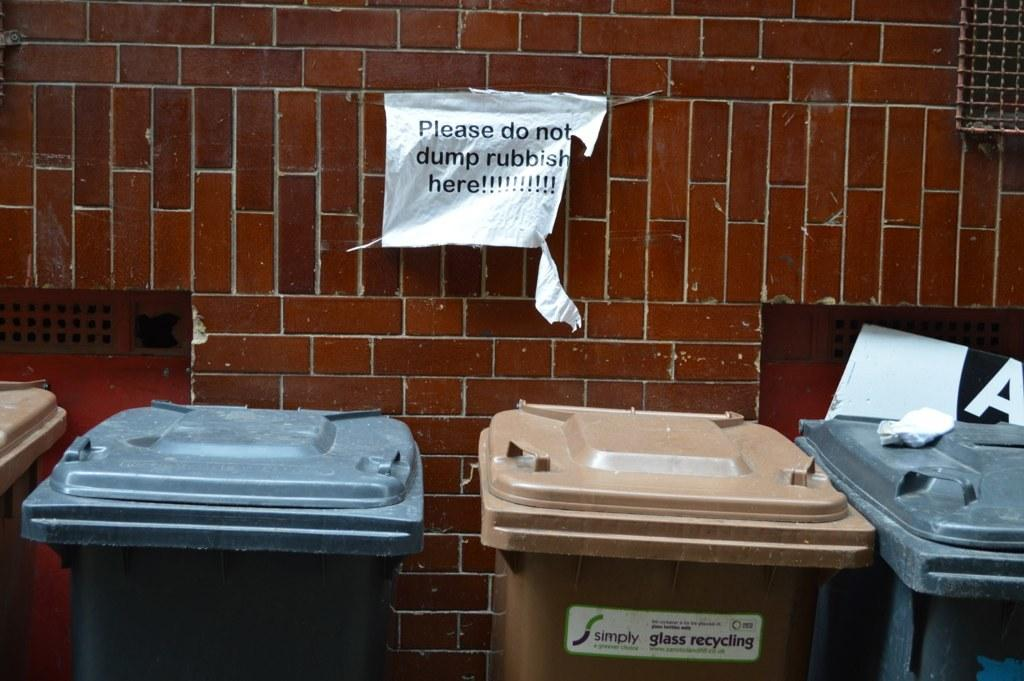Provide a one-sentence caption for the provided image. A row of trash cans outside a brick building with a sign saying Please do not dump rubish here. 